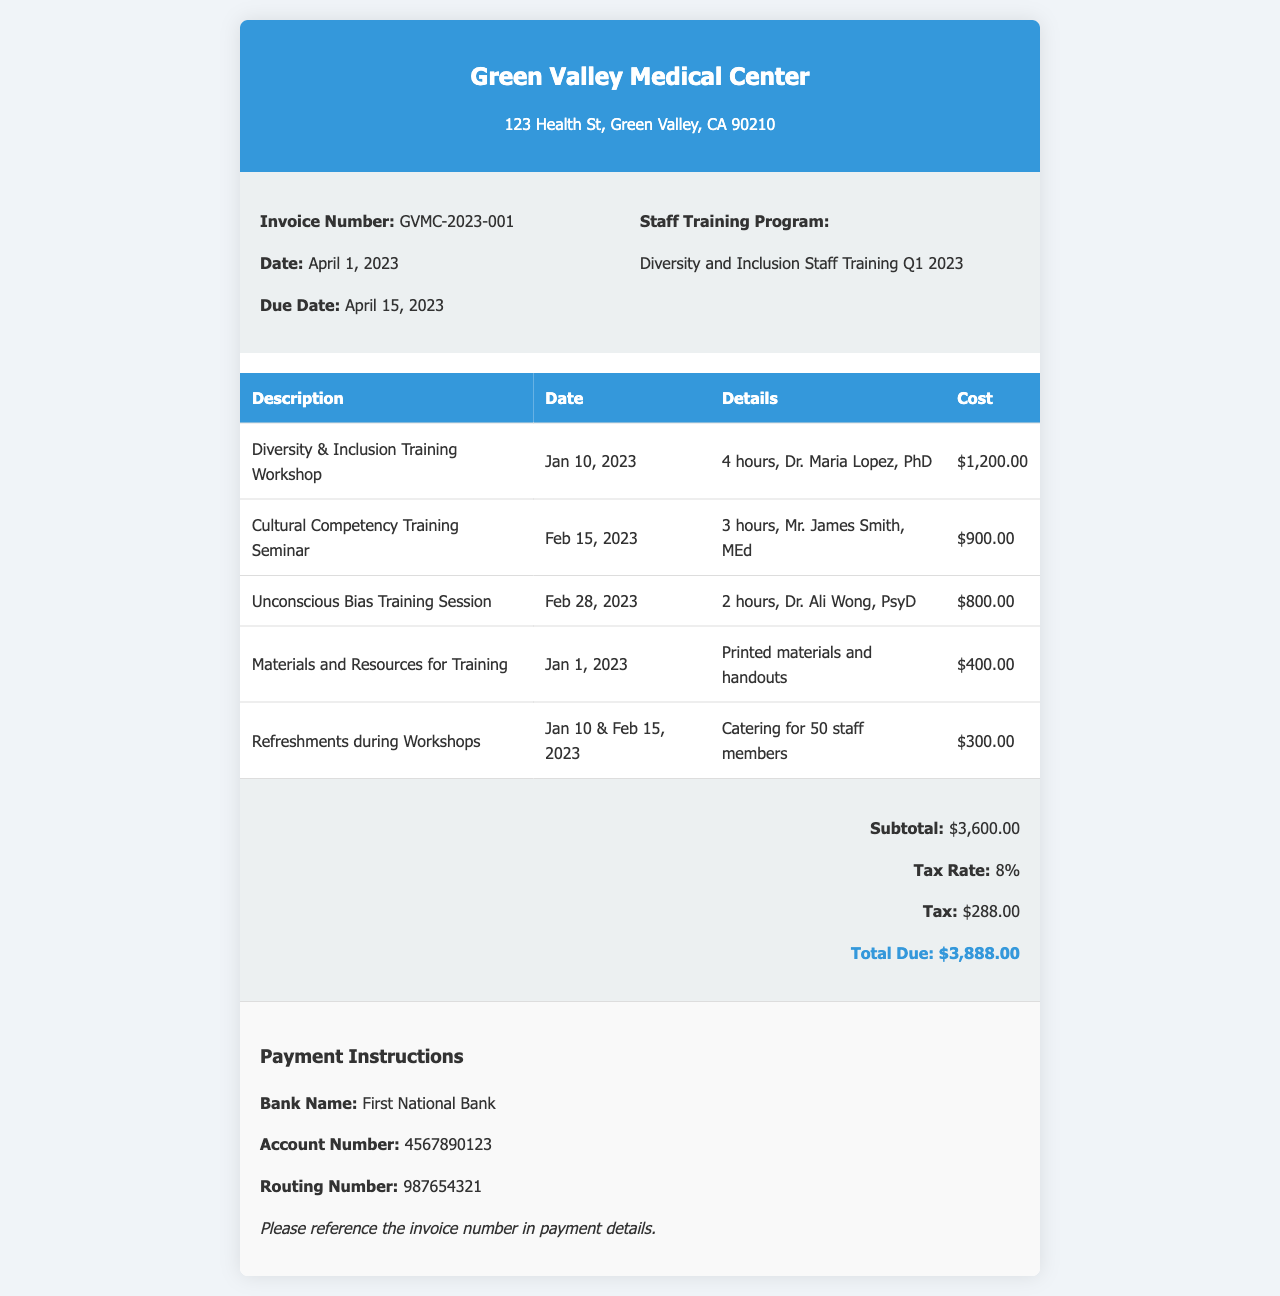What is the invoice number? The invoice number is clearly stated in the details section of the invoice.
Answer: GVMC-2023-001 When was the payment due? The due date for the payment is specified in the invoice details.
Answer: April 15, 2023 How much was spent on catering for the workshops? The invoice lists the cost for refreshments during workshops, showing total expenditure for catering.
Answer: $300.00 Who conducted the Unconscious Bias Training Session? The invoice provides the name of the instructor for the specific training session.
Answer: Dr. Ali Wong What is the subtotal of the invoice? The subtotal amount is explicitly mentioned in the total section of the document.
Answer: $3,600.00 What is the total amount due including tax? The total due is calculated by adding the subtotal and tax amounts in the invoice.
Answer: $3,888.00 How many hours did the Cultural Competency Training Seminar last? The duration of the seminar is indicated in the itemized expenses table.
Answer: 3 hours What is the tax rate applied to the invoice? The applicable tax rate is stated in the total section of the invoice.
Answer: 8% What type of training program is this invoice for? The invoice specifies the focus of the training program in its details section.
Answer: Diversity and Inclusion Staff Training Q1 2023 